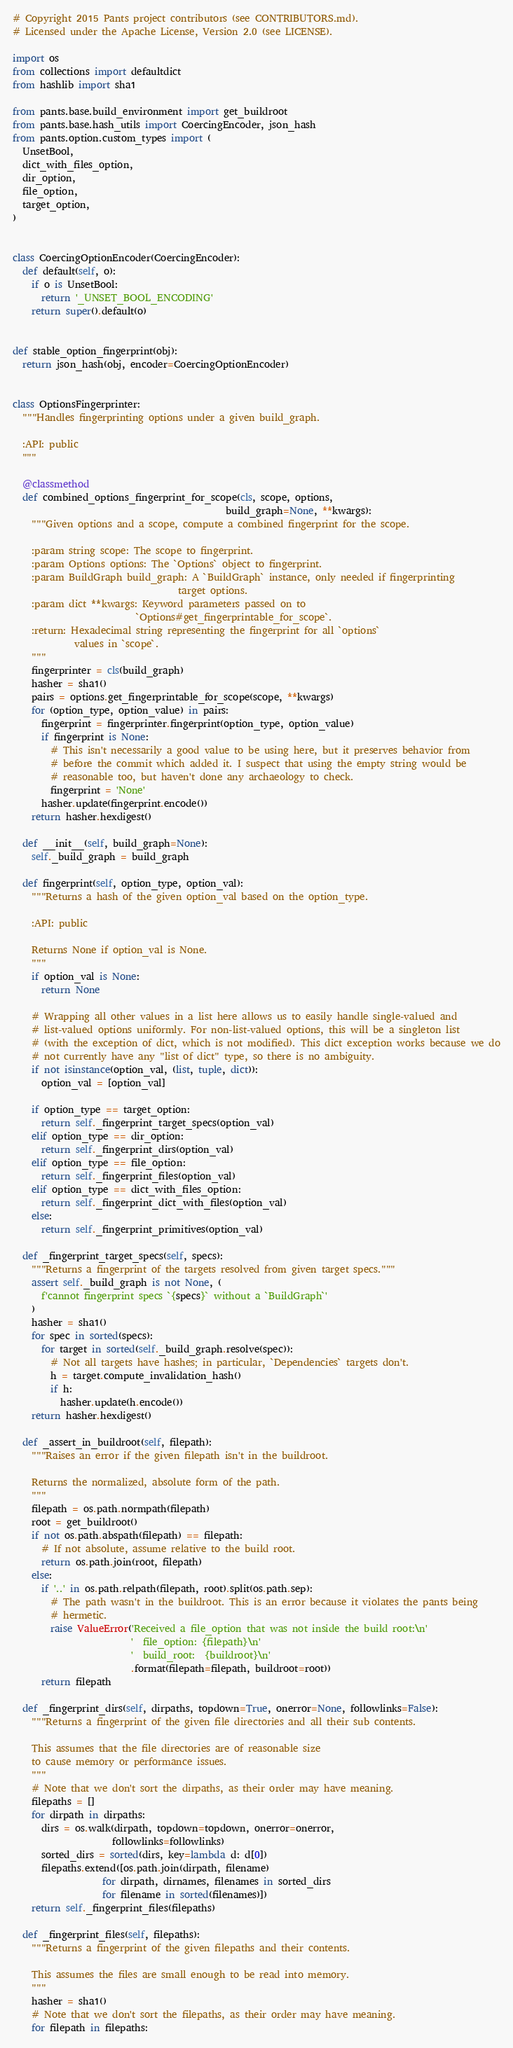<code> <loc_0><loc_0><loc_500><loc_500><_Python_># Copyright 2015 Pants project contributors (see CONTRIBUTORS.md).
# Licensed under the Apache License, Version 2.0 (see LICENSE).

import os
from collections import defaultdict
from hashlib import sha1

from pants.base.build_environment import get_buildroot
from pants.base.hash_utils import CoercingEncoder, json_hash
from pants.option.custom_types import (
  UnsetBool,
  dict_with_files_option,
  dir_option,
  file_option,
  target_option,
)


class CoercingOptionEncoder(CoercingEncoder):
  def default(self, o):
    if o is UnsetBool:
      return '_UNSET_BOOL_ENCODING'
    return super().default(o)


def stable_option_fingerprint(obj):
  return json_hash(obj, encoder=CoercingOptionEncoder)


class OptionsFingerprinter:
  """Handles fingerprinting options under a given build_graph.

  :API: public
  """

  @classmethod
  def combined_options_fingerprint_for_scope(cls, scope, options,
                                             build_graph=None, **kwargs):
    """Given options and a scope, compute a combined fingerprint for the scope.

    :param string scope: The scope to fingerprint.
    :param Options options: The `Options` object to fingerprint.
    :param BuildGraph build_graph: A `BuildGraph` instance, only needed if fingerprinting
                                   target options.
    :param dict **kwargs: Keyword parameters passed on to
                          `Options#get_fingerprintable_for_scope`.
    :return: Hexadecimal string representing the fingerprint for all `options`
             values in `scope`.
    """
    fingerprinter = cls(build_graph)
    hasher = sha1()
    pairs = options.get_fingerprintable_for_scope(scope, **kwargs)
    for (option_type, option_value) in pairs:
      fingerprint = fingerprinter.fingerprint(option_type, option_value)
      if fingerprint is None:
        # This isn't necessarily a good value to be using here, but it preserves behavior from
        # before the commit which added it. I suspect that using the empty string would be
        # reasonable too, but haven't done any archaeology to check.
        fingerprint = 'None'
      hasher.update(fingerprint.encode())
    return hasher.hexdigest()

  def __init__(self, build_graph=None):
    self._build_graph = build_graph

  def fingerprint(self, option_type, option_val):
    """Returns a hash of the given option_val based on the option_type.

    :API: public

    Returns None if option_val is None.
    """
    if option_val is None:
      return None

    # Wrapping all other values in a list here allows us to easily handle single-valued and
    # list-valued options uniformly. For non-list-valued options, this will be a singleton list
    # (with the exception of dict, which is not modified). This dict exception works because we do
    # not currently have any "list of dict" type, so there is no ambiguity.
    if not isinstance(option_val, (list, tuple, dict)):
      option_val = [option_val]

    if option_type == target_option:
      return self._fingerprint_target_specs(option_val)
    elif option_type == dir_option:
      return self._fingerprint_dirs(option_val)
    elif option_type == file_option:
      return self._fingerprint_files(option_val)
    elif option_type == dict_with_files_option:
      return self._fingerprint_dict_with_files(option_val)
    else:
      return self._fingerprint_primitives(option_val)

  def _fingerprint_target_specs(self, specs):
    """Returns a fingerprint of the targets resolved from given target specs."""
    assert self._build_graph is not None, (
      f'cannot fingerprint specs `{specs}` without a `BuildGraph`'
    )
    hasher = sha1()
    for spec in sorted(specs):
      for target in sorted(self._build_graph.resolve(spec)):
        # Not all targets have hashes; in particular, `Dependencies` targets don't.
        h = target.compute_invalidation_hash()
        if h:
          hasher.update(h.encode())
    return hasher.hexdigest()

  def _assert_in_buildroot(self, filepath):
    """Raises an error if the given filepath isn't in the buildroot.

    Returns the normalized, absolute form of the path.
    """
    filepath = os.path.normpath(filepath)
    root = get_buildroot()
    if not os.path.abspath(filepath) == filepath:
      # If not absolute, assume relative to the build root.
      return os.path.join(root, filepath)
    else:
      if '..' in os.path.relpath(filepath, root).split(os.path.sep):
        # The path wasn't in the buildroot. This is an error because it violates the pants being
        # hermetic.
        raise ValueError('Received a file_option that was not inside the build root:\n'
                         '  file_option: {filepath}\n'
                         '  build_root:  {buildroot}\n'
                         .format(filepath=filepath, buildroot=root))
      return filepath

  def _fingerprint_dirs(self, dirpaths, topdown=True, onerror=None, followlinks=False):
    """Returns a fingerprint of the given file directories and all their sub contents.

    This assumes that the file directories are of reasonable size
    to cause memory or performance issues.
    """
    # Note that we don't sort the dirpaths, as their order may have meaning.
    filepaths = []
    for dirpath in dirpaths:
      dirs = os.walk(dirpath, topdown=topdown, onerror=onerror,
                     followlinks=followlinks)
      sorted_dirs = sorted(dirs, key=lambda d: d[0])
      filepaths.extend([os.path.join(dirpath, filename)
                   for dirpath, dirnames, filenames in sorted_dirs
                   for filename in sorted(filenames)])
    return self._fingerprint_files(filepaths)

  def _fingerprint_files(self, filepaths):
    """Returns a fingerprint of the given filepaths and their contents.

    This assumes the files are small enough to be read into memory.
    """
    hasher = sha1()
    # Note that we don't sort the filepaths, as their order may have meaning.
    for filepath in filepaths:</code> 